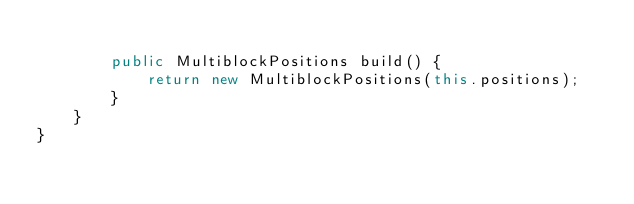<code> <loc_0><loc_0><loc_500><loc_500><_Java_>
        public MultiblockPositions build() {
            return new MultiblockPositions(this.positions);
        }
    }
}
</code> 